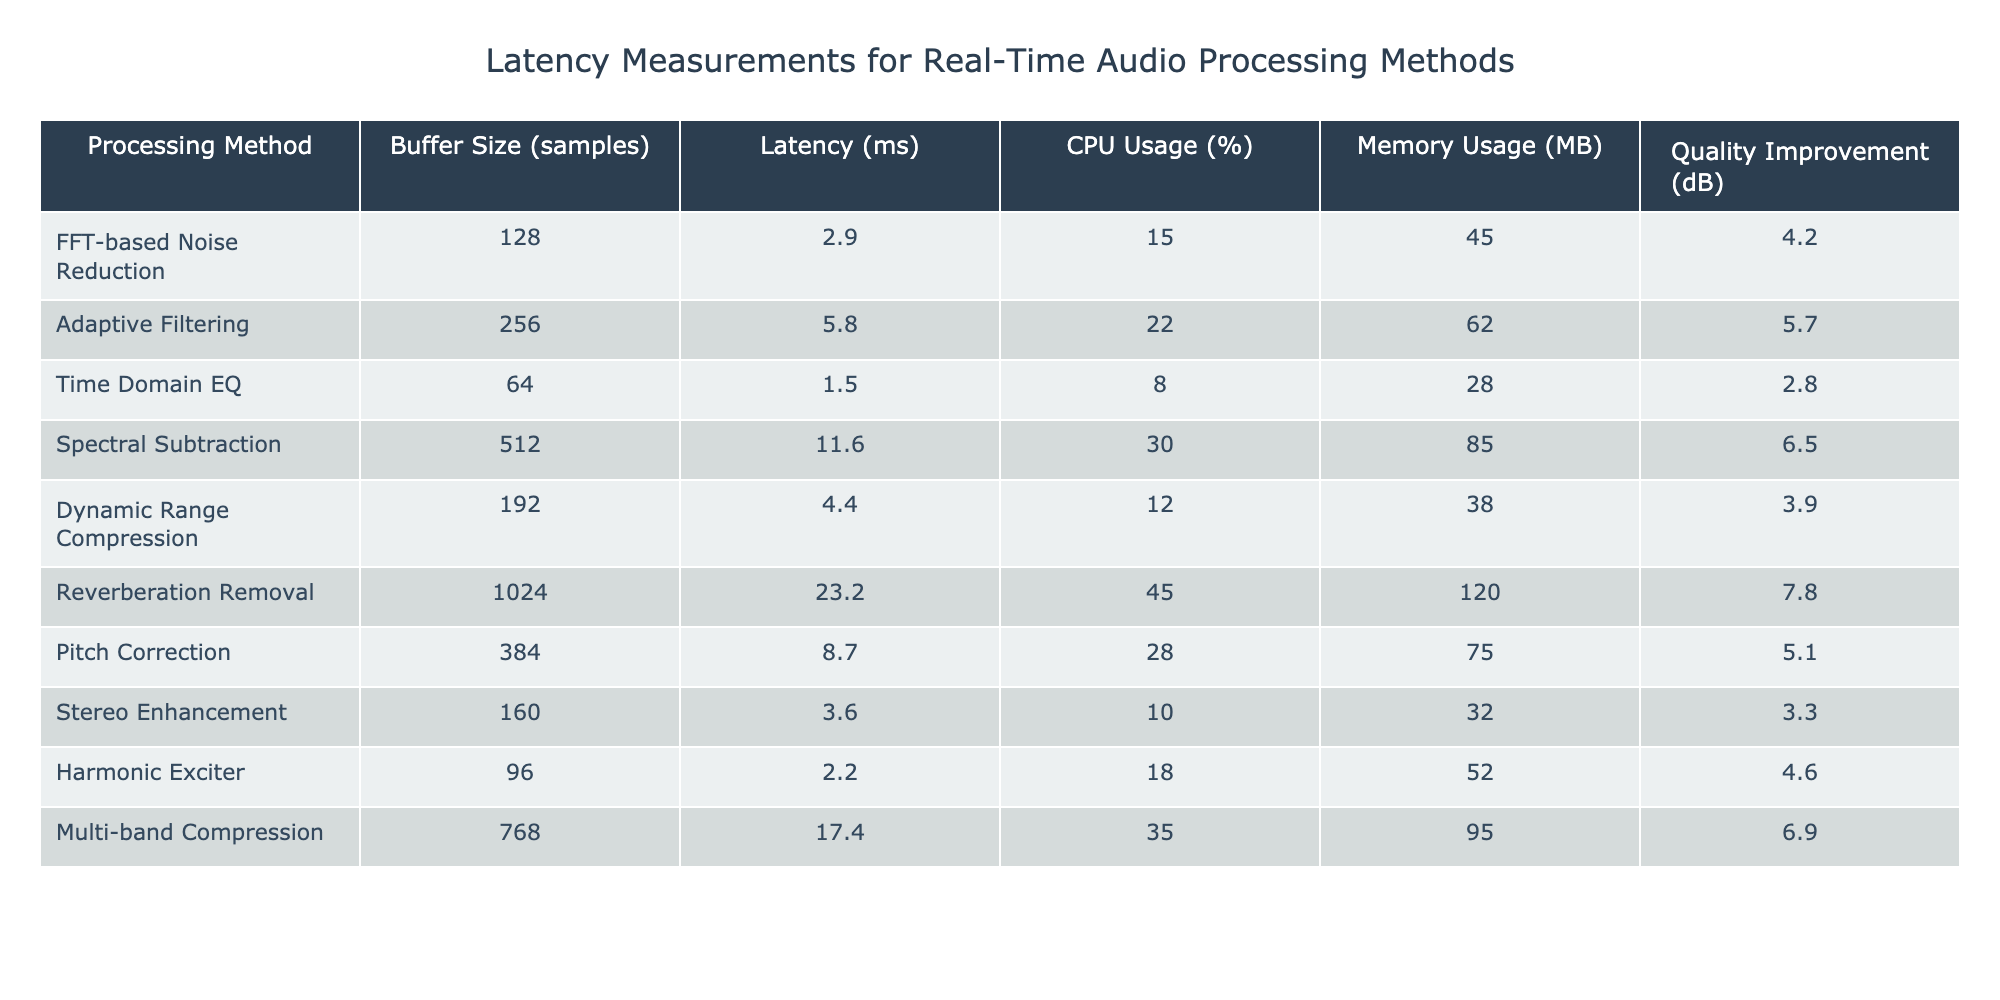What is the latency of the FFT-based Noise Reduction method? Looking at the "Latency (ms)" column for "FFT-based Noise Reduction," the value is 2.9 ms.
Answer: 2.9 ms Which processing method has the highest CPU usage? The "CPU Usage (%)" column indicates that "Reverberation Removal" has the highest usage at 45%.
Answer: Reverberation Removal What is the average latency across all processing methods? To find the average, sum the latency values (2.9 + 5.8 + 1.5 + 11.6 + 4.4 + 23.2 + 8.7 + 3.6 + 2.2 + 17.4) = 77.3 ms, and divide by the number of methods (10), resulting in 77.3 / 10 = 7.73 ms.
Answer: 7.73 ms Does the Adaptive Filtering method have better latency than the Spectral Subtraction method? Adaptive Filtering has a latency of 5.8 ms while Spectral Subtraction has a latency of 11.6 ms. Since 5.8 is less than 11.6, Adaptive Filtering does indeed have better latency.
Answer: Yes What is the memory usage difference between Dynamic Range Compression and Multi-band Compression? Memory usage for Dynamic Range Compression is 38 MB and for Multi-band Compression, it is 95 MB. The difference is 95 - 38 = 57 MB.
Answer: 57 MB Which processing method shows the highest quality improvement in decibels? By comparing the "Quality Improvement (dB)" values, "Reverberation Removal" has the highest at 7.8 dB.
Answer: Reverberation Removal What is the total CPU usage for the methods with a buffer size greater than 256 samples? The methods with buffer size greater than 256 are Reverberation Removal (45%), Pitch Correction (28%), and Multi-band Compression (35%). Their total CPU usage is 45 + 28 + 35 = 108%.
Answer: 108% Is the latency of Time Domain EQ lower than that of Pitch Correction? Time Domain EQ has a latency of 1.5 ms, while Pitch Correction has a latency of 8.7 ms. Since 1.5 is less than 8.7, the statement is true.
Answer: Yes What method has the lowest memory usage and what is that value? The "Memory Usage (MB)" column shows that Time Domain EQ has the lowest usage at 28 MB.
Answer: Time Domain EQ, 28 MB Which processing methods have a quality improvement greater than 5 dB? The methods with quality improvement greater than 5 dB are Adaptive Filtering (5.7 dB), Spectral Subtraction (6.5 dB), Reverberation Removal (7.8 dB), and Multi-band Compression (6.9 dB).
Answer: 4 methods 